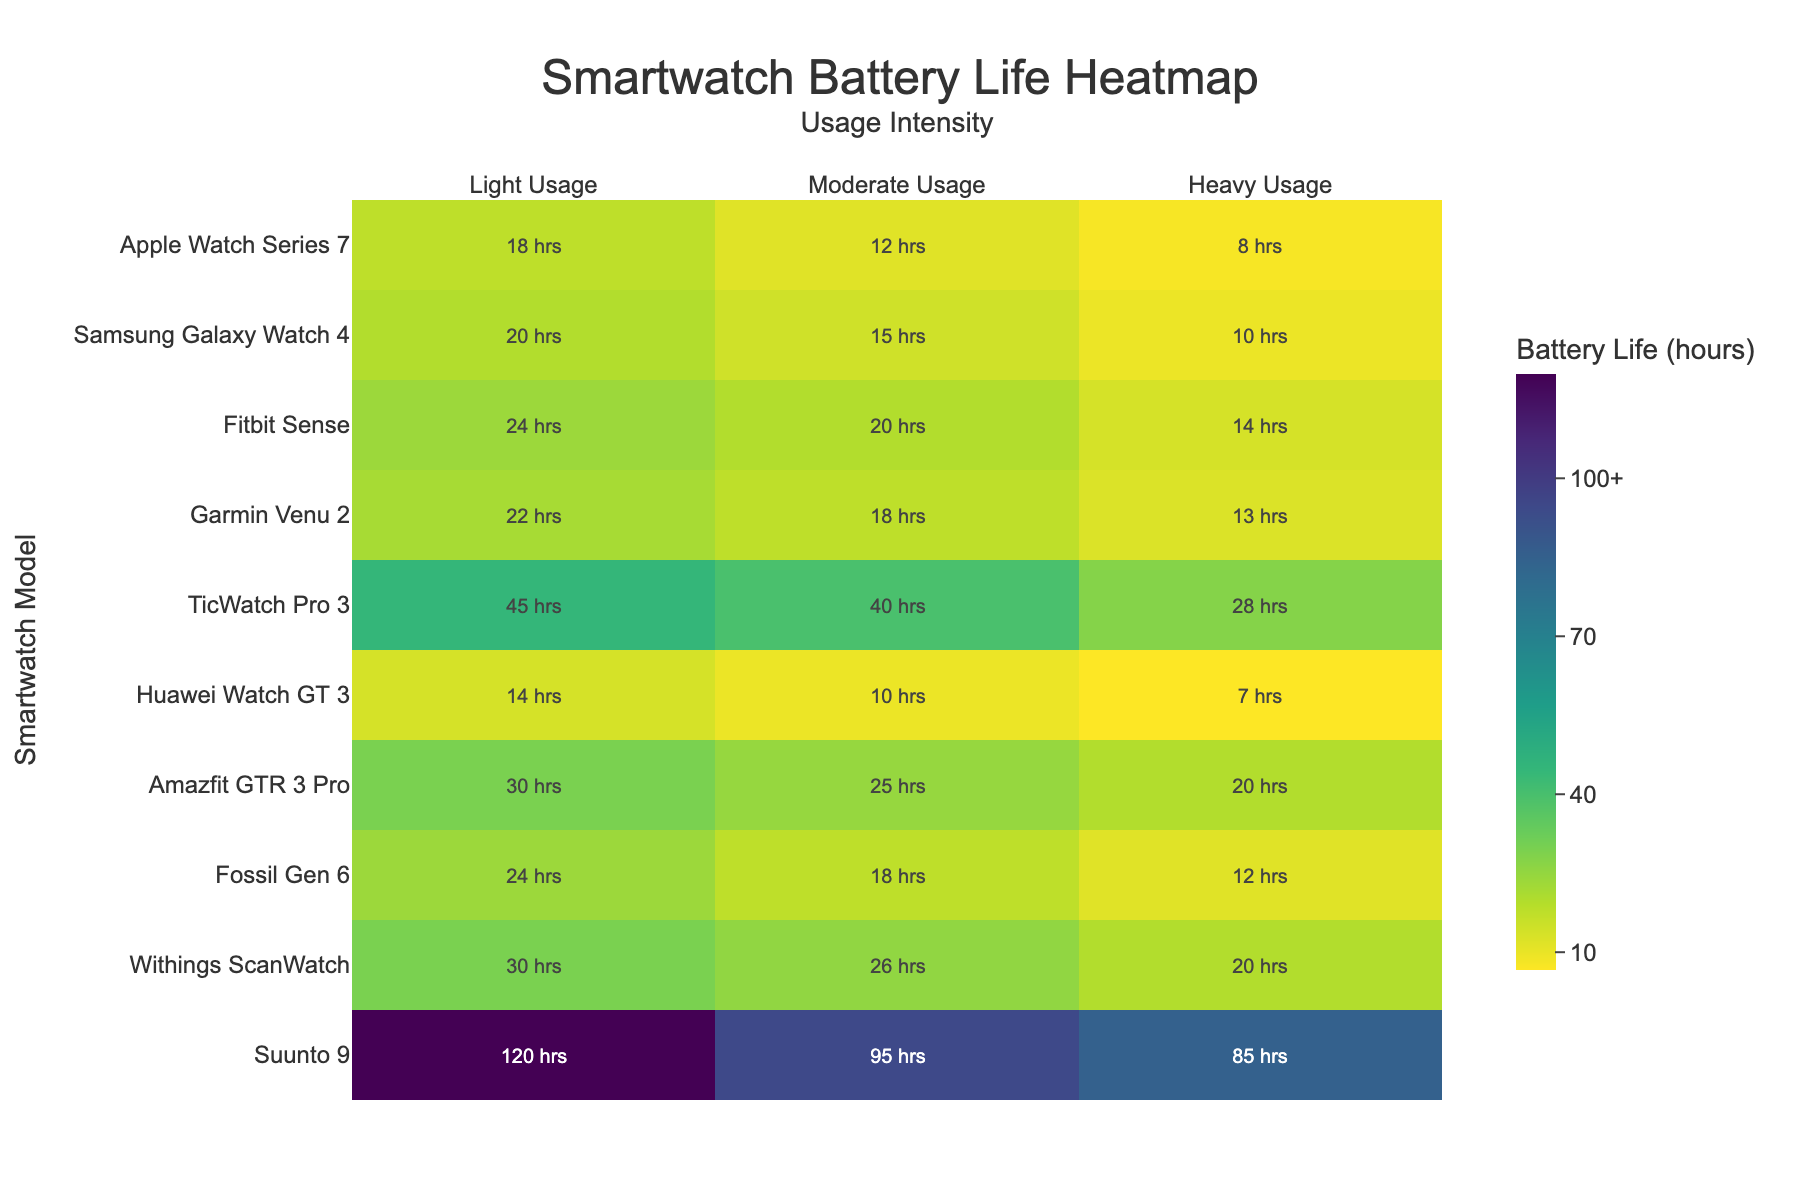Which smartwatch has the longest battery life under heavy usage? The chart shows battery life for heavy usage across models in the last column. The TicWatch Pro 3 has the longest battery life under heavy usage.
Answer: TicWatch Pro 3 What is the title of the heatmap? The title is displayed at the top of the heatmap.
Answer: Smartwatch Battery Life Heatmap How does the light usage battery life of the Samsung Galaxy Watch 4 compare to the Fitbit Sense? Find the values for light usage by looking at the first column for both models. Samsung Galaxy Watch 4 has 20 hours and Fitbit Sense has 24 hours, so the Fitbit Sense has more battery life under light usage.
Answer: Fitbit Sense has more What is the difference in moderate usage battery life between the Suunto 9 and the Garmin Venu 2? Find values for moderate usage in the middle column: Suunto 9 has 95 hours and Garmin Venu 2 has 18 hours. The difference is 95 - 18.
Answer: 77 hours What are the x-axis labels? The x-axis labels are displayed at the top of each column.
Answer: Light Usage, Moderate Usage, Heavy Usage Which smartwatches have a battery life greater than 20 hours for light usage but less than 25 hours for moderate usage? Check the first column for light usage and the middle column for moderate usage. The Apple Watch Series 7 and Garmin Venu 2 meet this criteria.
Answer: Apple Watch Series 7, Garmin Venu 2 What is the average battery life under heavy usage across all models? Add the heavy usage values from the last column and divide by the number of models: (8 + 10 + 14 + 13 + 28 + 7 + 20 + 12 + 20 + 85) / 10. The sum is 217 hours, average is 217/10.
Answer: 21.7 hours How is the color scale organized? The color scale uses a Viridis color scheme and is likely to show varying shades from dark to light representing lower to higher values.
Answer: Viridis scale Which smartwatch model shows the greatest discrepancy between light and moderate usage battery life? Calculate the difference between light and moderate usage for each model and identify the largest one. The TicWatch Pro 3 has 45 - 40 = 5 hours, while other models have differences like 18 - 12 = 6 hours for Apple Watch Series 7. Fossil Gen 6 has 24 - 18 = 6 hours. The exact steps for all models confirm that Suunto 9 with 120 - 95 = 25 hours is the greatest discrepancy.
Answer: Suunto 9 